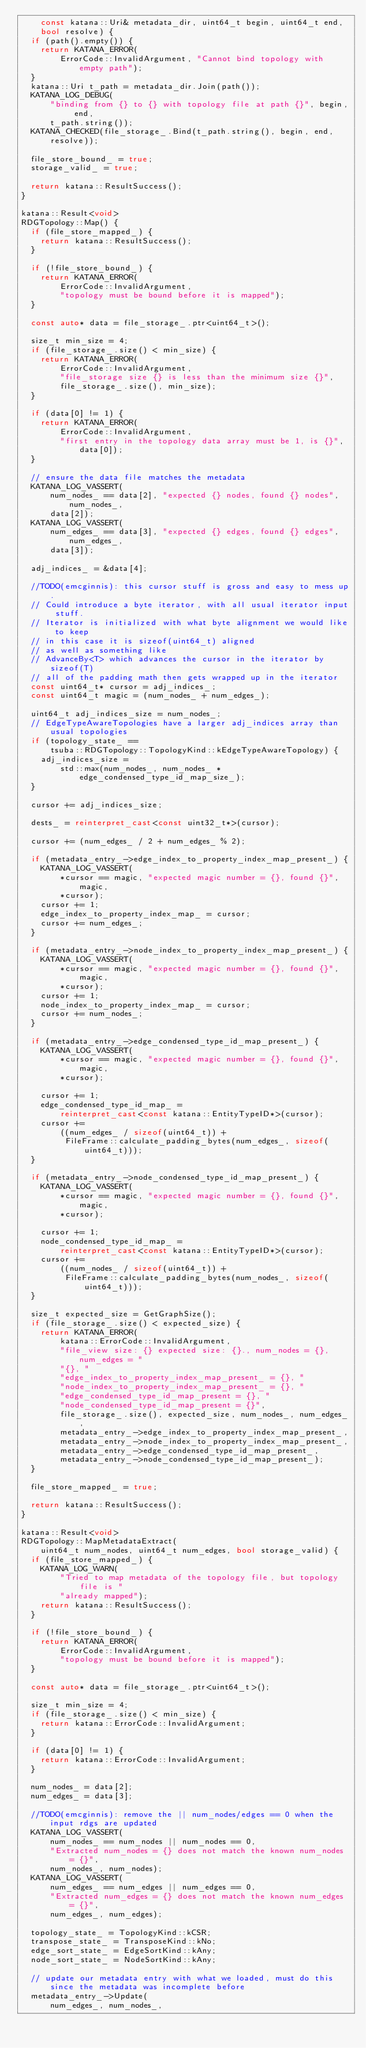Convert code to text. <code><loc_0><loc_0><loc_500><loc_500><_C++_>    const katana::Uri& metadata_dir, uint64_t begin, uint64_t end,
    bool resolve) {
  if (path().empty()) {
    return KATANA_ERROR(
        ErrorCode::InvalidArgument, "Cannot bind topology with empty path");
  }
  katana::Uri t_path = metadata_dir.Join(path());
  KATANA_LOG_DEBUG(
      "binding from {} to {} with topology file at path {}", begin, end,
      t_path.string());
  KATANA_CHECKED(file_storage_.Bind(t_path.string(), begin, end, resolve));

  file_store_bound_ = true;
  storage_valid_ = true;

  return katana::ResultSuccess();
}

katana::Result<void>
RDGTopology::Map() {
  if (file_store_mapped_) {
    return katana::ResultSuccess();
  }

  if (!file_store_bound_) {
    return KATANA_ERROR(
        ErrorCode::InvalidArgument,
        "topology must be bound before it is mapped");
  }

  const auto* data = file_storage_.ptr<uint64_t>();

  size_t min_size = 4;
  if (file_storage_.size() < min_size) {
    return KATANA_ERROR(
        ErrorCode::InvalidArgument,
        "file_storage size {} is less than the minimum size {}",
        file_storage_.size(), min_size);
  }

  if (data[0] != 1) {
    return KATANA_ERROR(
        ErrorCode::InvalidArgument,
        "first entry in the topology data array must be 1, is {}", data[0]);
  }

  // ensure the data file matches the metadata
  KATANA_LOG_VASSERT(
      num_nodes_ == data[2], "expected {} nodes, found {} nodes", num_nodes_,
      data[2]);
  KATANA_LOG_VASSERT(
      num_edges_ == data[3], "expected {} edges, found {} edges", num_edges_,
      data[3]);

  adj_indices_ = &data[4];

  //TODO(emcginnis): this cursor stuff is gross and easy to mess up.
  // Could introduce a byte iterator, with all usual iterator input stuff.
  // Iterator is initialized with what byte alignment we would like to keep
  // in this case it is sizeof(uint64_t) aligned
  // as well as something like
  // AdvanceBy<T> which advances the cursor in the iterator by sizeof(T)
  // all of the padding math then gets wrapped up in the iterator
  const uint64_t* cursor = adj_indices_;
  const uint64_t magic = (num_nodes_ + num_edges_);

  uint64_t adj_indices_size = num_nodes_;
  // EdgeTypeAwareTopologies have a larger adj_indices array than usual topologies
  if (topology_state_ ==
      tsuba::RDGTopology::TopologyKind::kEdgeTypeAwareTopology) {
    adj_indices_size =
        std::max(num_nodes_, num_nodes_ * edge_condensed_type_id_map_size_);
  }

  cursor += adj_indices_size;

  dests_ = reinterpret_cast<const uint32_t*>(cursor);

  cursor += (num_edges_ / 2 + num_edges_ % 2);

  if (metadata_entry_->edge_index_to_property_index_map_present_) {
    KATANA_LOG_VASSERT(
        *cursor == magic, "expected magic number = {}, found {}", magic,
        *cursor);
    cursor += 1;
    edge_index_to_property_index_map_ = cursor;
    cursor += num_edges_;
  }

  if (metadata_entry_->node_index_to_property_index_map_present_) {
    KATANA_LOG_VASSERT(
        *cursor == magic, "expected magic number = {}, found {}", magic,
        *cursor);
    cursor += 1;
    node_index_to_property_index_map_ = cursor;
    cursor += num_nodes_;
  }

  if (metadata_entry_->edge_condensed_type_id_map_present_) {
    KATANA_LOG_VASSERT(
        *cursor == magic, "expected magic number = {}, found {}", magic,
        *cursor);

    cursor += 1;
    edge_condensed_type_id_map_ =
        reinterpret_cast<const katana::EntityTypeID*>(cursor);
    cursor +=
        ((num_edges_ / sizeof(uint64_t)) +
         FileFrame::calculate_padding_bytes(num_edges_, sizeof(uint64_t)));
  }

  if (metadata_entry_->node_condensed_type_id_map_present_) {
    KATANA_LOG_VASSERT(
        *cursor == magic, "expected magic number = {}, found {}", magic,
        *cursor);

    cursor += 1;
    node_condensed_type_id_map_ =
        reinterpret_cast<const katana::EntityTypeID*>(cursor);
    cursor +=
        ((num_nodes_ / sizeof(uint64_t)) +
         FileFrame::calculate_padding_bytes(num_nodes_, sizeof(uint64_t)));
  }

  size_t expected_size = GetGraphSize();
  if (file_storage_.size() < expected_size) {
    return KATANA_ERROR(
        katana::ErrorCode::InvalidArgument,
        "file_view size: {} expected size: {}., num_nodes = {}, num_edges = "
        "{}, "
        "edge_index_to_property_index_map_present_ = {}, "
        "node_index_to_property_index_map_present_ = {}, "
        "edge_condensed_type_id_map_present = {}, "
        "node_condensed_type_id_map_present = {}",
        file_storage_.size(), expected_size, num_nodes_, num_edges_,
        metadata_entry_->edge_index_to_property_index_map_present_,
        metadata_entry_->node_index_to_property_index_map_present_,
        metadata_entry_->edge_condensed_type_id_map_present_,
        metadata_entry_->node_condensed_type_id_map_present_);
  }

  file_store_mapped_ = true;

  return katana::ResultSuccess();
}

katana::Result<void>
RDGTopology::MapMetadataExtract(
    uint64_t num_nodes, uint64_t num_edges, bool storage_valid) {
  if (file_store_mapped_) {
    KATANA_LOG_WARN(
        "Tried to map metadata of the topology file, but topology file is "
        "already mapped");
    return katana::ResultSuccess();
  }

  if (!file_store_bound_) {
    return KATANA_ERROR(
        ErrorCode::InvalidArgument,
        "topology must be bound before it is mapped");
  }

  const auto* data = file_storage_.ptr<uint64_t>();

  size_t min_size = 4;
  if (file_storage_.size() < min_size) {
    return katana::ErrorCode::InvalidArgument;
  }

  if (data[0] != 1) {
    return katana::ErrorCode::InvalidArgument;
  }

  num_nodes_ = data[2];
  num_edges_ = data[3];

  //TODO(emcginnis): remove the || num_nodes/edges == 0 when the input rdgs are updated
  KATANA_LOG_VASSERT(
      num_nodes_ == num_nodes || num_nodes == 0,
      "Extracted num_nodes = {} does not match the known num_nodes = {}",
      num_nodes_, num_nodes);
  KATANA_LOG_VASSERT(
      num_edges_ == num_edges || num_edges == 0,
      "Extracted num_edges = {} does not match the known num_edges = {}",
      num_edges_, num_edges);

  topology_state_ = TopologyKind::kCSR;
  transpose_state_ = TransposeKind::kNo;
  edge_sort_state_ = EdgeSortKind::kAny;
  node_sort_state_ = NodeSortKind::kAny;

  // update our metadata entry with what we loaded, must do this since the metadata was incomplete before
  metadata_entry_->Update(
      num_edges_, num_nodes_,</code> 